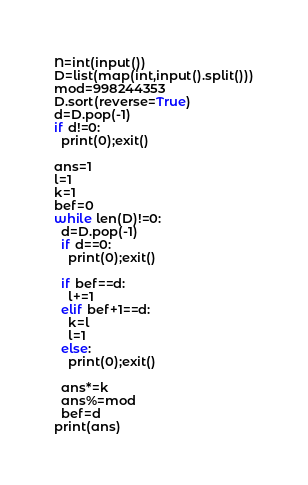<code> <loc_0><loc_0><loc_500><loc_500><_Python_>N=int(input())
D=list(map(int,input().split()))
mod=998244353
D.sort(reverse=True)
d=D.pop(-1)
if d!=0:
  print(0);exit()

ans=1
l=1
k=1
bef=0
while len(D)!=0:
  d=D.pop(-1)
  if d==0:
    print(0);exit()
  
  if bef==d:
    l+=1
  elif bef+1==d:
    k=l
    l=1
  else:
    print(0);exit()
    
  ans*=k
  ans%=mod
  bef=d
print(ans)</code> 